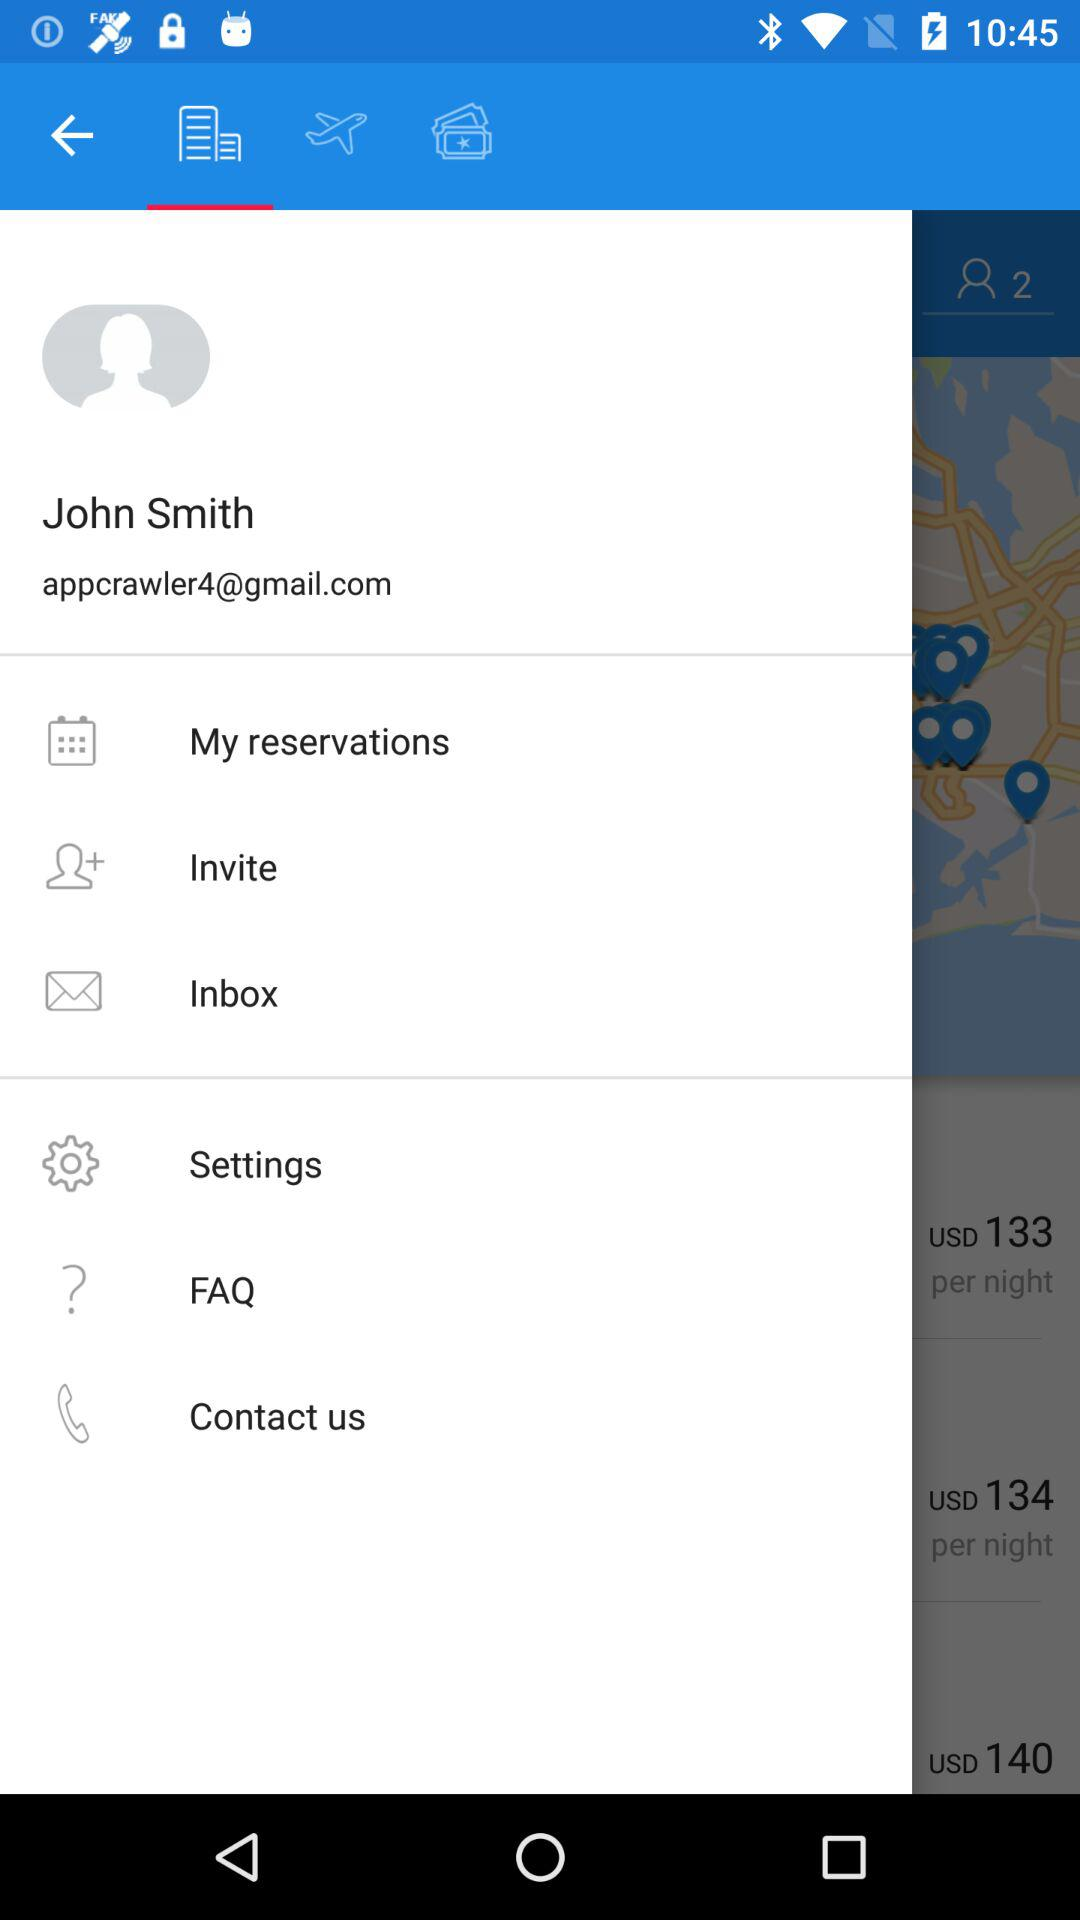What is the email address? The email address is appcrawler4@gmail.com. 